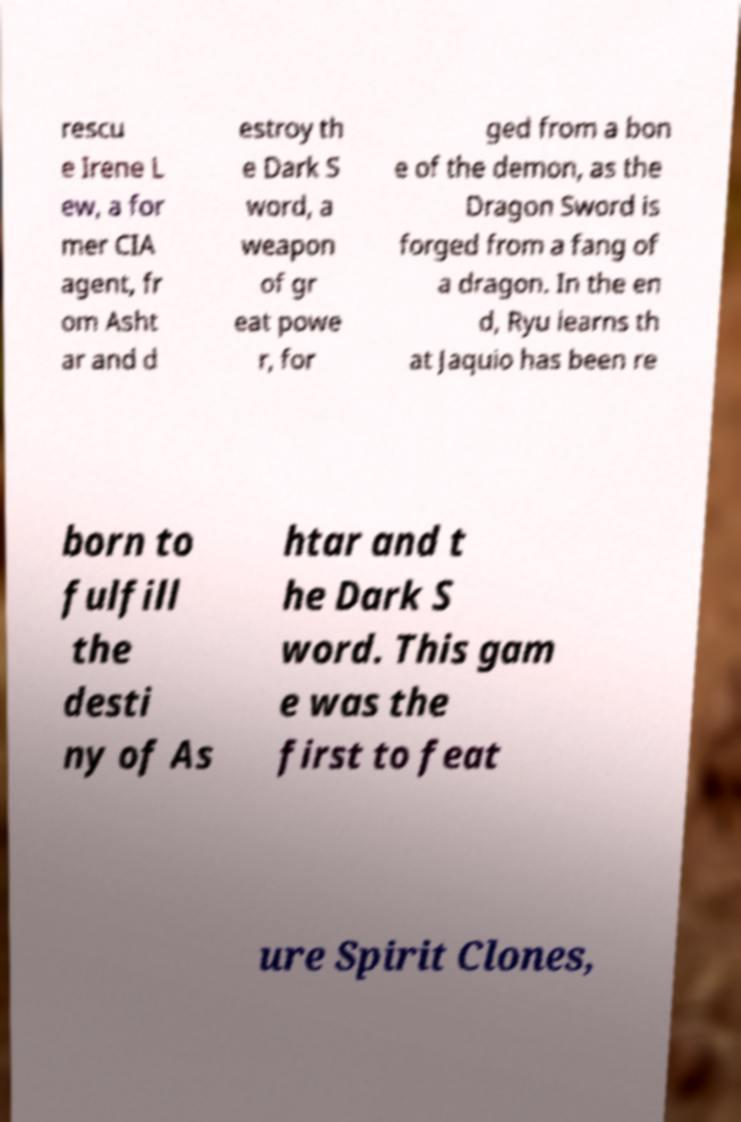Could you assist in decoding the text presented in this image and type it out clearly? rescu e Irene L ew, a for mer CIA agent, fr om Asht ar and d estroy th e Dark S word, a weapon of gr eat powe r, for ged from a bon e of the demon, as the Dragon Sword is forged from a fang of a dragon. In the en d, Ryu learns th at Jaquio has been re born to fulfill the desti ny of As htar and t he Dark S word. This gam e was the first to feat ure Spirit Clones, 